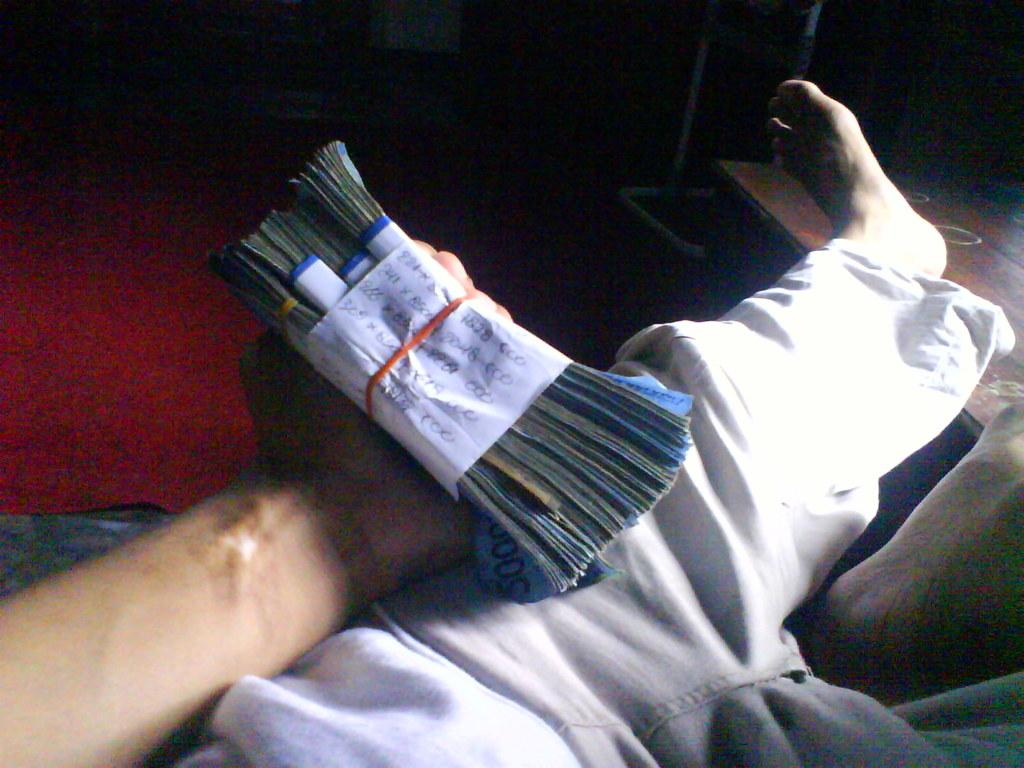What is the main subject of the image? There is a person in the image. What is the person holding in the image? The person is holding bundles of currency notes. What can be seen in the background of the image? There is a red carpet, a table, and a stand in the background of the image. How would you describe the lighting in the image? The background of the image is dark. What type of design or development is being discussed by the maid in the image? There is no maid present in the image, and no discussion about design or development is taking place. 